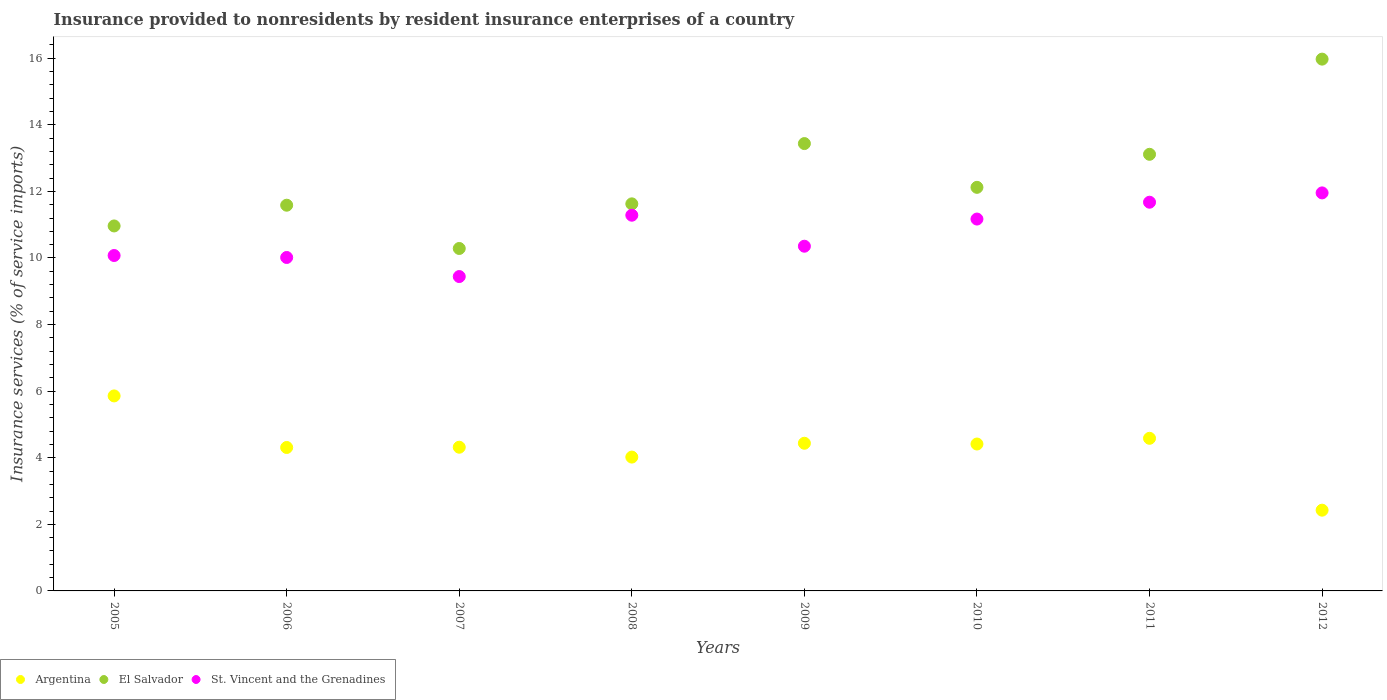What is the insurance provided to nonresidents in St. Vincent and the Grenadines in 2010?
Your answer should be very brief. 11.17. Across all years, what is the maximum insurance provided to nonresidents in El Salvador?
Your answer should be compact. 15.97. Across all years, what is the minimum insurance provided to nonresidents in St. Vincent and the Grenadines?
Keep it short and to the point. 9.44. In which year was the insurance provided to nonresidents in St. Vincent and the Grenadines maximum?
Your answer should be compact. 2012. In which year was the insurance provided to nonresidents in Argentina minimum?
Make the answer very short. 2012. What is the total insurance provided to nonresidents in El Salvador in the graph?
Offer a terse response. 99.11. What is the difference between the insurance provided to nonresidents in Argentina in 2005 and that in 2012?
Provide a succinct answer. 3.43. What is the difference between the insurance provided to nonresidents in St. Vincent and the Grenadines in 2011 and the insurance provided to nonresidents in El Salvador in 2010?
Your answer should be very brief. -0.45. What is the average insurance provided to nonresidents in St. Vincent and the Grenadines per year?
Provide a short and direct response. 10.75. In the year 2009, what is the difference between the insurance provided to nonresidents in St. Vincent and the Grenadines and insurance provided to nonresidents in El Salvador?
Make the answer very short. -3.08. What is the ratio of the insurance provided to nonresidents in St. Vincent and the Grenadines in 2005 to that in 2012?
Your answer should be very brief. 0.84. Is the difference between the insurance provided to nonresidents in St. Vincent and the Grenadines in 2005 and 2009 greater than the difference between the insurance provided to nonresidents in El Salvador in 2005 and 2009?
Your answer should be compact. Yes. What is the difference between the highest and the second highest insurance provided to nonresidents in Argentina?
Offer a terse response. 1.27. What is the difference between the highest and the lowest insurance provided to nonresidents in St. Vincent and the Grenadines?
Your response must be concise. 2.51. In how many years, is the insurance provided to nonresidents in Argentina greater than the average insurance provided to nonresidents in Argentina taken over all years?
Make the answer very short. 6. Is it the case that in every year, the sum of the insurance provided to nonresidents in El Salvador and insurance provided to nonresidents in Argentina  is greater than the insurance provided to nonresidents in St. Vincent and the Grenadines?
Offer a very short reply. Yes. How many years are there in the graph?
Your answer should be compact. 8. What is the difference between two consecutive major ticks on the Y-axis?
Keep it short and to the point. 2. Are the values on the major ticks of Y-axis written in scientific E-notation?
Your answer should be very brief. No. Where does the legend appear in the graph?
Your response must be concise. Bottom left. How are the legend labels stacked?
Provide a short and direct response. Horizontal. What is the title of the graph?
Your response must be concise. Insurance provided to nonresidents by resident insurance enterprises of a country. What is the label or title of the X-axis?
Your response must be concise. Years. What is the label or title of the Y-axis?
Provide a succinct answer. Insurance services (% of service imports). What is the Insurance services (% of service imports) in Argentina in 2005?
Offer a very short reply. 5.86. What is the Insurance services (% of service imports) in El Salvador in 2005?
Keep it short and to the point. 10.96. What is the Insurance services (% of service imports) in St. Vincent and the Grenadines in 2005?
Give a very brief answer. 10.07. What is the Insurance services (% of service imports) in Argentina in 2006?
Provide a short and direct response. 4.31. What is the Insurance services (% of service imports) in El Salvador in 2006?
Give a very brief answer. 11.59. What is the Insurance services (% of service imports) in St. Vincent and the Grenadines in 2006?
Make the answer very short. 10.02. What is the Insurance services (% of service imports) of Argentina in 2007?
Make the answer very short. 4.32. What is the Insurance services (% of service imports) of El Salvador in 2007?
Provide a short and direct response. 10.29. What is the Insurance services (% of service imports) of St. Vincent and the Grenadines in 2007?
Offer a very short reply. 9.44. What is the Insurance services (% of service imports) of Argentina in 2008?
Keep it short and to the point. 4.02. What is the Insurance services (% of service imports) of El Salvador in 2008?
Your answer should be very brief. 11.63. What is the Insurance services (% of service imports) in St. Vincent and the Grenadines in 2008?
Your answer should be compact. 11.28. What is the Insurance services (% of service imports) of Argentina in 2009?
Offer a very short reply. 4.44. What is the Insurance services (% of service imports) in El Salvador in 2009?
Your answer should be very brief. 13.44. What is the Insurance services (% of service imports) in St. Vincent and the Grenadines in 2009?
Your answer should be very brief. 10.35. What is the Insurance services (% of service imports) of Argentina in 2010?
Ensure brevity in your answer.  4.41. What is the Insurance services (% of service imports) of El Salvador in 2010?
Provide a succinct answer. 12.12. What is the Insurance services (% of service imports) in St. Vincent and the Grenadines in 2010?
Your answer should be very brief. 11.17. What is the Insurance services (% of service imports) in Argentina in 2011?
Keep it short and to the point. 4.58. What is the Insurance services (% of service imports) in El Salvador in 2011?
Provide a short and direct response. 13.11. What is the Insurance services (% of service imports) of St. Vincent and the Grenadines in 2011?
Provide a short and direct response. 11.68. What is the Insurance services (% of service imports) of Argentina in 2012?
Provide a succinct answer. 2.43. What is the Insurance services (% of service imports) of El Salvador in 2012?
Offer a terse response. 15.97. What is the Insurance services (% of service imports) of St. Vincent and the Grenadines in 2012?
Your answer should be very brief. 11.95. Across all years, what is the maximum Insurance services (% of service imports) in Argentina?
Your answer should be very brief. 5.86. Across all years, what is the maximum Insurance services (% of service imports) of El Salvador?
Provide a succinct answer. 15.97. Across all years, what is the maximum Insurance services (% of service imports) in St. Vincent and the Grenadines?
Make the answer very short. 11.95. Across all years, what is the minimum Insurance services (% of service imports) in Argentina?
Give a very brief answer. 2.43. Across all years, what is the minimum Insurance services (% of service imports) in El Salvador?
Ensure brevity in your answer.  10.29. Across all years, what is the minimum Insurance services (% of service imports) of St. Vincent and the Grenadines?
Your answer should be very brief. 9.44. What is the total Insurance services (% of service imports) in Argentina in the graph?
Give a very brief answer. 34.36. What is the total Insurance services (% of service imports) in El Salvador in the graph?
Offer a very short reply. 99.11. What is the total Insurance services (% of service imports) of St. Vincent and the Grenadines in the graph?
Your response must be concise. 85.97. What is the difference between the Insurance services (% of service imports) of Argentina in 2005 and that in 2006?
Give a very brief answer. 1.55. What is the difference between the Insurance services (% of service imports) of El Salvador in 2005 and that in 2006?
Offer a terse response. -0.62. What is the difference between the Insurance services (% of service imports) of St. Vincent and the Grenadines in 2005 and that in 2006?
Provide a succinct answer. 0.06. What is the difference between the Insurance services (% of service imports) in Argentina in 2005 and that in 2007?
Offer a very short reply. 1.54. What is the difference between the Insurance services (% of service imports) in El Salvador in 2005 and that in 2007?
Give a very brief answer. 0.68. What is the difference between the Insurance services (% of service imports) in St. Vincent and the Grenadines in 2005 and that in 2007?
Ensure brevity in your answer.  0.63. What is the difference between the Insurance services (% of service imports) in Argentina in 2005 and that in 2008?
Your answer should be very brief. 1.84. What is the difference between the Insurance services (% of service imports) of El Salvador in 2005 and that in 2008?
Your answer should be very brief. -0.66. What is the difference between the Insurance services (% of service imports) of St. Vincent and the Grenadines in 2005 and that in 2008?
Provide a succinct answer. -1.21. What is the difference between the Insurance services (% of service imports) in Argentina in 2005 and that in 2009?
Your response must be concise. 1.42. What is the difference between the Insurance services (% of service imports) in El Salvador in 2005 and that in 2009?
Provide a short and direct response. -2.47. What is the difference between the Insurance services (% of service imports) of St. Vincent and the Grenadines in 2005 and that in 2009?
Your answer should be very brief. -0.28. What is the difference between the Insurance services (% of service imports) of Argentina in 2005 and that in 2010?
Offer a very short reply. 1.45. What is the difference between the Insurance services (% of service imports) of El Salvador in 2005 and that in 2010?
Ensure brevity in your answer.  -1.16. What is the difference between the Insurance services (% of service imports) of St. Vincent and the Grenadines in 2005 and that in 2010?
Offer a very short reply. -1.09. What is the difference between the Insurance services (% of service imports) of Argentina in 2005 and that in 2011?
Provide a succinct answer. 1.27. What is the difference between the Insurance services (% of service imports) of El Salvador in 2005 and that in 2011?
Your answer should be compact. -2.15. What is the difference between the Insurance services (% of service imports) of St. Vincent and the Grenadines in 2005 and that in 2011?
Your answer should be compact. -1.6. What is the difference between the Insurance services (% of service imports) in Argentina in 2005 and that in 2012?
Keep it short and to the point. 3.43. What is the difference between the Insurance services (% of service imports) in El Salvador in 2005 and that in 2012?
Offer a very short reply. -5.01. What is the difference between the Insurance services (% of service imports) in St. Vincent and the Grenadines in 2005 and that in 2012?
Ensure brevity in your answer.  -1.88. What is the difference between the Insurance services (% of service imports) in Argentina in 2006 and that in 2007?
Give a very brief answer. -0.01. What is the difference between the Insurance services (% of service imports) of El Salvador in 2006 and that in 2007?
Make the answer very short. 1.3. What is the difference between the Insurance services (% of service imports) in St. Vincent and the Grenadines in 2006 and that in 2007?
Give a very brief answer. 0.57. What is the difference between the Insurance services (% of service imports) of Argentina in 2006 and that in 2008?
Provide a short and direct response. 0.29. What is the difference between the Insurance services (% of service imports) of El Salvador in 2006 and that in 2008?
Give a very brief answer. -0.04. What is the difference between the Insurance services (% of service imports) of St. Vincent and the Grenadines in 2006 and that in 2008?
Offer a terse response. -1.27. What is the difference between the Insurance services (% of service imports) of Argentina in 2006 and that in 2009?
Give a very brief answer. -0.13. What is the difference between the Insurance services (% of service imports) in El Salvador in 2006 and that in 2009?
Your answer should be very brief. -1.85. What is the difference between the Insurance services (% of service imports) in St. Vincent and the Grenadines in 2006 and that in 2009?
Keep it short and to the point. -0.34. What is the difference between the Insurance services (% of service imports) in Argentina in 2006 and that in 2010?
Offer a very short reply. -0.1. What is the difference between the Insurance services (% of service imports) in El Salvador in 2006 and that in 2010?
Offer a terse response. -0.54. What is the difference between the Insurance services (% of service imports) of St. Vincent and the Grenadines in 2006 and that in 2010?
Your response must be concise. -1.15. What is the difference between the Insurance services (% of service imports) in Argentina in 2006 and that in 2011?
Provide a short and direct response. -0.28. What is the difference between the Insurance services (% of service imports) in El Salvador in 2006 and that in 2011?
Ensure brevity in your answer.  -1.53. What is the difference between the Insurance services (% of service imports) in St. Vincent and the Grenadines in 2006 and that in 2011?
Make the answer very short. -1.66. What is the difference between the Insurance services (% of service imports) in Argentina in 2006 and that in 2012?
Provide a succinct answer. 1.88. What is the difference between the Insurance services (% of service imports) of El Salvador in 2006 and that in 2012?
Offer a terse response. -4.39. What is the difference between the Insurance services (% of service imports) in St. Vincent and the Grenadines in 2006 and that in 2012?
Keep it short and to the point. -1.94. What is the difference between the Insurance services (% of service imports) of Argentina in 2007 and that in 2008?
Offer a very short reply. 0.3. What is the difference between the Insurance services (% of service imports) in El Salvador in 2007 and that in 2008?
Offer a very short reply. -1.34. What is the difference between the Insurance services (% of service imports) in St. Vincent and the Grenadines in 2007 and that in 2008?
Ensure brevity in your answer.  -1.84. What is the difference between the Insurance services (% of service imports) of Argentina in 2007 and that in 2009?
Offer a very short reply. -0.12. What is the difference between the Insurance services (% of service imports) of El Salvador in 2007 and that in 2009?
Make the answer very short. -3.15. What is the difference between the Insurance services (% of service imports) of St. Vincent and the Grenadines in 2007 and that in 2009?
Keep it short and to the point. -0.91. What is the difference between the Insurance services (% of service imports) in Argentina in 2007 and that in 2010?
Your answer should be very brief. -0.1. What is the difference between the Insurance services (% of service imports) in El Salvador in 2007 and that in 2010?
Offer a very short reply. -1.84. What is the difference between the Insurance services (% of service imports) in St. Vincent and the Grenadines in 2007 and that in 2010?
Offer a terse response. -1.73. What is the difference between the Insurance services (% of service imports) in Argentina in 2007 and that in 2011?
Make the answer very short. -0.27. What is the difference between the Insurance services (% of service imports) of El Salvador in 2007 and that in 2011?
Your answer should be very brief. -2.83. What is the difference between the Insurance services (% of service imports) in St. Vincent and the Grenadines in 2007 and that in 2011?
Ensure brevity in your answer.  -2.23. What is the difference between the Insurance services (% of service imports) in Argentina in 2007 and that in 2012?
Make the answer very short. 1.89. What is the difference between the Insurance services (% of service imports) of El Salvador in 2007 and that in 2012?
Your response must be concise. -5.69. What is the difference between the Insurance services (% of service imports) in St. Vincent and the Grenadines in 2007 and that in 2012?
Your answer should be compact. -2.51. What is the difference between the Insurance services (% of service imports) in Argentina in 2008 and that in 2009?
Make the answer very short. -0.42. What is the difference between the Insurance services (% of service imports) of El Salvador in 2008 and that in 2009?
Your answer should be very brief. -1.81. What is the difference between the Insurance services (% of service imports) in St. Vincent and the Grenadines in 2008 and that in 2009?
Make the answer very short. 0.93. What is the difference between the Insurance services (% of service imports) of Argentina in 2008 and that in 2010?
Your answer should be very brief. -0.39. What is the difference between the Insurance services (% of service imports) of El Salvador in 2008 and that in 2010?
Keep it short and to the point. -0.5. What is the difference between the Insurance services (% of service imports) in St. Vincent and the Grenadines in 2008 and that in 2010?
Your response must be concise. 0.12. What is the difference between the Insurance services (% of service imports) of Argentina in 2008 and that in 2011?
Offer a terse response. -0.56. What is the difference between the Insurance services (% of service imports) in El Salvador in 2008 and that in 2011?
Offer a very short reply. -1.49. What is the difference between the Insurance services (% of service imports) of St. Vincent and the Grenadines in 2008 and that in 2011?
Provide a succinct answer. -0.39. What is the difference between the Insurance services (% of service imports) of Argentina in 2008 and that in 2012?
Offer a terse response. 1.59. What is the difference between the Insurance services (% of service imports) in El Salvador in 2008 and that in 2012?
Provide a short and direct response. -4.35. What is the difference between the Insurance services (% of service imports) of St. Vincent and the Grenadines in 2008 and that in 2012?
Your response must be concise. -0.67. What is the difference between the Insurance services (% of service imports) in Argentina in 2009 and that in 2010?
Your response must be concise. 0.02. What is the difference between the Insurance services (% of service imports) of El Salvador in 2009 and that in 2010?
Your answer should be very brief. 1.31. What is the difference between the Insurance services (% of service imports) in St. Vincent and the Grenadines in 2009 and that in 2010?
Your answer should be compact. -0.82. What is the difference between the Insurance services (% of service imports) of Argentina in 2009 and that in 2011?
Offer a terse response. -0.15. What is the difference between the Insurance services (% of service imports) in El Salvador in 2009 and that in 2011?
Offer a very short reply. 0.32. What is the difference between the Insurance services (% of service imports) of St. Vincent and the Grenadines in 2009 and that in 2011?
Keep it short and to the point. -1.32. What is the difference between the Insurance services (% of service imports) in Argentina in 2009 and that in 2012?
Your answer should be very brief. 2.01. What is the difference between the Insurance services (% of service imports) in El Salvador in 2009 and that in 2012?
Keep it short and to the point. -2.54. What is the difference between the Insurance services (% of service imports) in St. Vincent and the Grenadines in 2009 and that in 2012?
Your response must be concise. -1.6. What is the difference between the Insurance services (% of service imports) in Argentina in 2010 and that in 2011?
Give a very brief answer. -0.17. What is the difference between the Insurance services (% of service imports) in El Salvador in 2010 and that in 2011?
Offer a very short reply. -0.99. What is the difference between the Insurance services (% of service imports) of St. Vincent and the Grenadines in 2010 and that in 2011?
Your answer should be very brief. -0.51. What is the difference between the Insurance services (% of service imports) in Argentina in 2010 and that in 2012?
Offer a very short reply. 1.99. What is the difference between the Insurance services (% of service imports) of El Salvador in 2010 and that in 2012?
Ensure brevity in your answer.  -3.85. What is the difference between the Insurance services (% of service imports) in St. Vincent and the Grenadines in 2010 and that in 2012?
Provide a succinct answer. -0.79. What is the difference between the Insurance services (% of service imports) in Argentina in 2011 and that in 2012?
Offer a terse response. 2.16. What is the difference between the Insurance services (% of service imports) in El Salvador in 2011 and that in 2012?
Make the answer very short. -2.86. What is the difference between the Insurance services (% of service imports) in St. Vincent and the Grenadines in 2011 and that in 2012?
Offer a terse response. -0.28. What is the difference between the Insurance services (% of service imports) of Argentina in 2005 and the Insurance services (% of service imports) of El Salvador in 2006?
Keep it short and to the point. -5.73. What is the difference between the Insurance services (% of service imports) of Argentina in 2005 and the Insurance services (% of service imports) of St. Vincent and the Grenadines in 2006?
Ensure brevity in your answer.  -4.16. What is the difference between the Insurance services (% of service imports) of El Salvador in 2005 and the Insurance services (% of service imports) of St. Vincent and the Grenadines in 2006?
Keep it short and to the point. 0.95. What is the difference between the Insurance services (% of service imports) in Argentina in 2005 and the Insurance services (% of service imports) in El Salvador in 2007?
Make the answer very short. -4.43. What is the difference between the Insurance services (% of service imports) of Argentina in 2005 and the Insurance services (% of service imports) of St. Vincent and the Grenadines in 2007?
Your answer should be very brief. -3.58. What is the difference between the Insurance services (% of service imports) in El Salvador in 2005 and the Insurance services (% of service imports) in St. Vincent and the Grenadines in 2007?
Your answer should be compact. 1.52. What is the difference between the Insurance services (% of service imports) of Argentina in 2005 and the Insurance services (% of service imports) of El Salvador in 2008?
Keep it short and to the point. -5.77. What is the difference between the Insurance services (% of service imports) of Argentina in 2005 and the Insurance services (% of service imports) of St. Vincent and the Grenadines in 2008?
Offer a terse response. -5.43. What is the difference between the Insurance services (% of service imports) of El Salvador in 2005 and the Insurance services (% of service imports) of St. Vincent and the Grenadines in 2008?
Provide a short and direct response. -0.32. What is the difference between the Insurance services (% of service imports) in Argentina in 2005 and the Insurance services (% of service imports) in El Salvador in 2009?
Your answer should be compact. -7.58. What is the difference between the Insurance services (% of service imports) of Argentina in 2005 and the Insurance services (% of service imports) of St. Vincent and the Grenadines in 2009?
Your answer should be very brief. -4.5. What is the difference between the Insurance services (% of service imports) in El Salvador in 2005 and the Insurance services (% of service imports) in St. Vincent and the Grenadines in 2009?
Give a very brief answer. 0.61. What is the difference between the Insurance services (% of service imports) in Argentina in 2005 and the Insurance services (% of service imports) in El Salvador in 2010?
Provide a succinct answer. -6.26. What is the difference between the Insurance services (% of service imports) of Argentina in 2005 and the Insurance services (% of service imports) of St. Vincent and the Grenadines in 2010?
Offer a very short reply. -5.31. What is the difference between the Insurance services (% of service imports) in El Salvador in 2005 and the Insurance services (% of service imports) in St. Vincent and the Grenadines in 2010?
Offer a very short reply. -0.21. What is the difference between the Insurance services (% of service imports) of Argentina in 2005 and the Insurance services (% of service imports) of El Salvador in 2011?
Your answer should be very brief. -7.26. What is the difference between the Insurance services (% of service imports) of Argentina in 2005 and the Insurance services (% of service imports) of St. Vincent and the Grenadines in 2011?
Ensure brevity in your answer.  -5.82. What is the difference between the Insurance services (% of service imports) in El Salvador in 2005 and the Insurance services (% of service imports) in St. Vincent and the Grenadines in 2011?
Your answer should be compact. -0.71. What is the difference between the Insurance services (% of service imports) in Argentina in 2005 and the Insurance services (% of service imports) in El Salvador in 2012?
Your answer should be compact. -10.12. What is the difference between the Insurance services (% of service imports) of Argentina in 2005 and the Insurance services (% of service imports) of St. Vincent and the Grenadines in 2012?
Offer a very short reply. -6.1. What is the difference between the Insurance services (% of service imports) of El Salvador in 2005 and the Insurance services (% of service imports) of St. Vincent and the Grenadines in 2012?
Your response must be concise. -0.99. What is the difference between the Insurance services (% of service imports) in Argentina in 2006 and the Insurance services (% of service imports) in El Salvador in 2007?
Provide a short and direct response. -5.98. What is the difference between the Insurance services (% of service imports) of Argentina in 2006 and the Insurance services (% of service imports) of St. Vincent and the Grenadines in 2007?
Your answer should be compact. -5.13. What is the difference between the Insurance services (% of service imports) of El Salvador in 2006 and the Insurance services (% of service imports) of St. Vincent and the Grenadines in 2007?
Provide a succinct answer. 2.14. What is the difference between the Insurance services (% of service imports) in Argentina in 2006 and the Insurance services (% of service imports) in El Salvador in 2008?
Your response must be concise. -7.32. What is the difference between the Insurance services (% of service imports) of Argentina in 2006 and the Insurance services (% of service imports) of St. Vincent and the Grenadines in 2008?
Your answer should be compact. -6.98. What is the difference between the Insurance services (% of service imports) in El Salvador in 2006 and the Insurance services (% of service imports) in St. Vincent and the Grenadines in 2008?
Ensure brevity in your answer.  0.3. What is the difference between the Insurance services (% of service imports) of Argentina in 2006 and the Insurance services (% of service imports) of El Salvador in 2009?
Give a very brief answer. -9.13. What is the difference between the Insurance services (% of service imports) in Argentina in 2006 and the Insurance services (% of service imports) in St. Vincent and the Grenadines in 2009?
Give a very brief answer. -6.05. What is the difference between the Insurance services (% of service imports) in El Salvador in 2006 and the Insurance services (% of service imports) in St. Vincent and the Grenadines in 2009?
Make the answer very short. 1.23. What is the difference between the Insurance services (% of service imports) in Argentina in 2006 and the Insurance services (% of service imports) in El Salvador in 2010?
Keep it short and to the point. -7.81. What is the difference between the Insurance services (% of service imports) in Argentina in 2006 and the Insurance services (% of service imports) in St. Vincent and the Grenadines in 2010?
Your answer should be very brief. -6.86. What is the difference between the Insurance services (% of service imports) in El Salvador in 2006 and the Insurance services (% of service imports) in St. Vincent and the Grenadines in 2010?
Your answer should be very brief. 0.42. What is the difference between the Insurance services (% of service imports) of Argentina in 2006 and the Insurance services (% of service imports) of El Salvador in 2011?
Ensure brevity in your answer.  -8.81. What is the difference between the Insurance services (% of service imports) of Argentina in 2006 and the Insurance services (% of service imports) of St. Vincent and the Grenadines in 2011?
Give a very brief answer. -7.37. What is the difference between the Insurance services (% of service imports) in El Salvador in 2006 and the Insurance services (% of service imports) in St. Vincent and the Grenadines in 2011?
Your answer should be compact. -0.09. What is the difference between the Insurance services (% of service imports) in Argentina in 2006 and the Insurance services (% of service imports) in El Salvador in 2012?
Provide a succinct answer. -11.66. What is the difference between the Insurance services (% of service imports) of Argentina in 2006 and the Insurance services (% of service imports) of St. Vincent and the Grenadines in 2012?
Provide a short and direct response. -7.65. What is the difference between the Insurance services (% of service imports) in El Salvador in 2006 and the Insurance services (% of service imports) in St. Vincent and the Grenadines in 2012?
Your answer should be compact. -0.37. What is the difference between the Insurance services (% of service imports) in Argentina in 2007 and the Insurance services (% of service imports) in El Salvador in 2008?
Make the answer very short. -7.31. What is the difference between the Insurance services (% of service imports) of Argentina in 2007 and the Insurance services (% of service imports) of St. Vincent and the Grenadines in 2008?
Ensure brevity in your answer.  -6.97. What is the difference between the Insurance services (% of service imports) in El Salvador in 2007 and the Insurance services (% of service imports) in St. Vincent and the Grenadines in 2008?
Make the answer very short. -1. What is the difference between the Insurance services (% of service imports) of Argentina in 2007 and the Insurance services (% of service imports) of El Salvador in 2009?
Make the answer very short. -9.12. What is the difference between the Insurance services (% of service imports) in Argentina in 2007 and the Insurance services (% of service imports) in St. Vincent and the Grenadines in 2009?
Keep it short and to the point. -6.04. What is the difference between the Insurance services (% of service imports) of El Salvador in 2007 and the Insurance services (% of service imports) of St. Vincent and the Grenadines in 2009?
Your answer should be compact. -0.07. What is the difference between the Insurance services (% of service imports) in Argentina in 2007 and the Insurance services (% of service imports) in El Salvador in 2010?
Make the answer very short. -7.81. What is the difference between the Insurance services (% of service imports) in Argentina in 2007 and the Insurance services (% of service imports) in St. Vincent and the Grenadines in 2010?
Provide a succinct answer. -6.85. What is the difference between the Insurance services (% of service imports) in El Salvador in 2007 and the Insurance services (% of service imports) in St. Vincent and the Grenadines in 2010?
Provide a short and direct response. -0.88. What is the difference between the Insurance services (% of service imports) of Argentina in 2007 and the Insurance services (% of service imports) of El Salvador in 2011?
Your answer should be very brief. -8.8. What is the difference between the Insurance services (% of service imports) in Argentina in 2007 and the Insurance services (% of service imports) in St. Vincent and the Grenadines in 2011?
Provide a short and direct response. -7.36. What is the difference between the Insurance services (% of service imports) in El Salvador in 2007 and the Insurance services (% of service imports) in St. Vincent and the Grenadines in 2011?
Provide a succinct answer. -1.39. What is the difference between the Insurance services (% of service imports) of Argentina in 2007 and the Insurance services (% of service imports) of El Salvador in 2012?
Your answer should be very brief. -11.66. What is the difference between the Insurance services (% of service imports) of Argentina in 2007 and the Insurance services (% of service imports) of St. Vincent and the Grenadines in 2012?
Ensure brevity in your answer.  -7.64. What is the difference between the Insurance services (% of service imports) in El Salvador in 2007 and the Insurance services (% of service imports) in St. Vincent and the Grenadines in 2012?
Keep it short and to the point. -1.67. What is the difference between the Insurance services (% of service imports) in Argentina in 2008 and the Insurance services (% of service imports) in El Salvador in 2009?
Provide a succinct answer. -9.42. What is the difference between the Insurance services (% of service imports) in Argentina in 2008 and the Insurance services (% of service imports) in St. Vincent and the Grenadines in 2009?
Your response must be concise. -6.33. What is the difference between the Insurance services (% of service imports) of El Salvador in 2008 and the Insurance services (% of service imports) of St. Vincent and the Grenadines in 2009?
Offer a very short reply. 1.27. What is the difference between the Insurance services (% of service imports) of Argentina in 2008 and the Insurance services (% of service imports) of El Salvador in 2010?
Your answer should be very brief. -8.1. What is the difference between the Insurance services (% of service imports) of Argentina in 2008 and the Insurance services (% of service imports) of St. Vincent and the Grenadines in 2010?
Give a very brief answer. -7.15. What is the difference between the Insurance services (% of service imports) in El Salvador in 2008 and the Insurance services (% of service imports) in St. Vincent and the Grenadines in 2010?
Give a very brief answer. 0.46. What is the difference between the Insurance services (% of service imports) of Argentina in 2008 and the Insurance services (% of service imports) of El Salvador in 2011?
Provide a short and direct response. -9.09. What is the difference between the Insurance services (% of service imports) of Argentina in 2008 and the Insurance services (% of service imports) of St. Vincent and the Grenadines in 2011?
Give a very brief answer. -7.66. What is the difference between the Insurance services (% of service imports) in El Salvador in 2008 and the Insurance services (% of service imports) in St. Vincent and the Grenadines in 2011?
Provide a short and direct response. -0.05. What is the difference between the Insurance services (% of service imports) in Argentina in 2008 and the Insurance services (% of service imports) in El Salvador in 2012?
Keep it short and to the point. -11.95. What is the difference between the Insurance services (% of service imports) in Argentina in 2008 and the Insurance services (% of service imports) in St. Vincent and the Grenadines in 2012?
Your response must be concise. -7.94. What is the difference between the Insurance services (% of service imports) of El Salvador in 2008 and the Insurance services (% of service imports) of St. Vincent and the Grenadines in 2012?
Ensure brevity in your answer.  -0.33. What is the difference between the Insurance services (% of service imports) in Argentina in 2009 and the Insurance services (% of service imports) in El Salvador in 2010?
Keep it short and to the point. -7.69. What is the difference between the Insurance services (% of service imports) of Argentina in 2009 and the Insurance services (% of service imports) of St. Vincent and the Grenadines in 2010?
Keep it short and to the point. -6.73. What is the difference between the Insurance services (% of service imports) in El Salvador in 2009 and the Insurance services (% of service imports) in St. Vincent and the Grenadines in 2010?
Make the answer very short. 2.27. What is the difference between the Insurance services (% of service imports) in Argentina in 2009 and the Insurance services (% of service imports) in El Salvador in 2011?
Offer a very short reply. -8.68. What is the difference between the Insurance services (% of service imports) in Argentina in 2009 and the Insurance services (% of service imports) in St. Vincent and the Grenadines in 2011?
Offer a terse response. -7.24. What is the difference between the Insurance services (% of service imports) in El Salvador in 2009 and the Insurance services (% of service imports) in St. Vincent and the Grenadines in 2011?
Your response must be concise. 1.76. What is the difference between the Insurance services (% of service imports) in Argentina in 2009 and the Insurance services (% of service imports) in El Salvador in 2012?
Offer a very short reply. -11.54. What is the difference between the Insurance services (% of service imports) of Argentina in 2009 and the Insurance services (% of service imports) of St. Vincent and the Grenadines in 2012?
Ensure brevity in your answer.  -7.52. What is the difference between the Insurance services (% of service imports) in El Salvador in 2009 and the Insurance services (% of service imports) in St. Vincent and the Grenadines in 2012?
Give a very brief answer. 1.48. What is the difference between the Insurance services (% of service imports) of Argentina in 2010 and the Insurance services (% of service imports) of El Salvador in 2011?
Offer a very short reply. -8.7. What is the difference between the Insurance services (% of service imports) of Argentina in 2010 and the Insurance services (% of service imports) of St. Vincent and the Grenadines in 2011?
Give a very brief answer. -7.26. What is the difference between the Insurance services (% of service imports) in El Salvador in 2010 and the Insurance services (% of service imports) in St. Vincent and the Grenadines in 2011?
Offer a terse response. 0.45. What is the difference between the Insurance services (% of service imports) in Argentina in 2010 and the Insurance services (% of service imports) in El Salvador in 2012?
Your response must be concise. -11.56. What is the difference between the Insurance services (% of service imports) of Argentina in 2010 and the Insurance services (% of service imports) of St. Vincent and the Grenadines in 2012?
Your response must be concise. -7.54. What is the difference between the Insurance services (% of service imports) of El Salvador in 2010 and the Insurance services (% of service imports) of St. Vincent and the Grenadines in 2012?
Keep it short and to the point. 0.17. What is the difference between the Insurance services (% of service imports) in Argentina in 2011 and the Insurance services (% of service imports) in El Salvador in 2012?
Provide a short and direct response. -11.39. What is the difference between the Insurance services (% of service imports) of Argentina in 2011 and the Insurance services (% of service imports) of St. Vincent and the Grenadines in 2012?
Offer a terse response. -7.37. What is the difference between the Insurance services (% of service imports) in El Salvador in 2011 and the Insurance services (% of service imports) in St. Vincent and the Grenadines in 2012?
Provide a succinct answer. 1.16. What is the average Insurance services (% of service imports) in Argentina per year?
Your answer should be very brief. 4.29. What is the average Insurance services (% of service imports) in El Salvador per year?
Offer a very short reply. 12.39. What is the average Insurance services (% of service imports) in St. Vincent and the Grenadines per year?
Your response must be concise. 10.75. In the year 2005, what is the difference between the Insurance services (% of service imports) of Argentina and Insurance services (% of service imports) of El Salvador?
Provide a short and direct response. -5.11. In the year 2005, what is the difference between the Insurance services (% of service imports) of Argentina and Insurance services (% of service imports) of St. Vincent and the Grenadines?
Give a very brief answer. -4.22. In the year 2005, what is the difference between the Insurance services (% of service imports) of El Salvador and Insurance services (% of service imports) of St. Vincent and the Grenadines?
Provide a succinct answer. 0.89. In the year 2006, what is the difference between the Insurance services (% of service imports) of Argentina and Insurance services (% of service imports) of El Salvador?
Your response must be concise. -7.28. In the year 2006, what is the difference between the Insurance services (% of service imports) of Argentina and Insurance services (% of service imports) of St. Vincent and the Grenadines?
Your answer should be compact. -5.71. In the year 2006, what is the difference between the Insurance services (% of service imports) in El Salvador and Insurance services (% of service imports) in St. Vincent and the Grenadines?
Give a very brief answer. 1.57. In the year 2007, what is the difference between the Insurance services (% of service imports) in Argentina and Insurance services (% of service imports) in El Salvador?
Your answer should be compact. -5.97. In the year 2007, what is the difference between the Insurance services (% of service imports) in Argentina and Insurance services (% of service imports) in St. Vincent and the Grenadines?
Provide a succinct answer. -5.13. In the year 2007, what is the difference between the Insurance services (% of service imports) of El Salvador and Insurance services (% of service imports) of St. Vincent and the Grenadines?
Offer a terse response. 0.84. In the year 2008, what is the difference between the Insurance services (% of service imports) of Argentina and Insurance services (% of service imports) of El Salvador?
Provide a succinct answer. -7.61. In the year 2008, what is the difference between the Insurance services (% of service imports) in Argentina and Insurance services (% of service imports) in St. Vincent and the Grenadines?
Ensure brevity in your answer.  -7.26. In the year 2008, what is the difference between the Insurance services (% of service imports) in El Salvador and Insurance services (% of service imports) in St. Vincent and the Grenadines?
Keep it short and to the point. 0.34. In the year 2009, what is the difference between the Insurance services (% of service imports) in Argentina and Insurance services (% of service imports) in El Salvador?
Provide a short and direct response. -9. In the year 2009, what is the difference between the Insurance services (% of service imports) in Argentina and Insurance services (% of service imports) in St. Vincent and the Grenadines?
Ensure brevity in your answer.  -5.92. In the year 2009, what is the difference between the Insurance services (% of service imports) of El Salvador and Insurance services (% of service imports) of St. Vincent and the Grenadines?
Provide a succinct answer. 3.08. In the year 2010, what is the difference between the Insurance services (% of service imports) in Argentina and Insurance services (% of service imports) in El Salvador?
Your answer should be compact. -7.71. In the year 2010, what is the difference between the Insurance services (% of service imports) of Argentina and Insurance services (% of service imports) of St. Vincent and the Grenadines?
Your answer should be compact. -6.76. In the year 2010, what is the difference between the Insurance services (% of service imports) in El Salvador and Insurance services (% of service imports) in St. Vincent and the Grenadines?
Offer a terse response. 0.95. In the year 2011, what is the difference between the Insurance services (% of service imports) of Argentina and Insurance services (% of service imports) of El Salvador?
Ensure brevity in your answer.  -8.53. In the year 2011, what is the difference between the Insurance services (% of service imports) in Argentina and Insurance services (% of service imports) in St. Vincent and the Grenadines?
Give a very brief answer. -7.09. In the year 2011, what is the difference between the Insurance services (% of service imports) in El Salvador and Insurance services (% of service imports) in St. Vincent and the Grenadines?
Your answer should be compact. 1.44. In the year 2012, what is the difference between the Insurance services (% of service imports) of Argentina and Insurance services (% of service imports) of El Salvador?
Offer a terse response. -13.55. In the year 2012, what is the difference between the Insurance services (% of service imports) of Argentina and Insurance services (% of service imports) of St. Vincent and the Grenadines?
Offer a very short reply. -9.53. In the year 2012, what is the difference between the Insurance services (% of service imports) in El Salvador and Insurance services (% of service imports) in St. Vincent and the Grenadines?
Provide a short and direct response. 4.02. What is the ratio of the Insurance services (% of service imports) of Argentina in 2005 to that in 2006?
Ensure brevity in your answer.  1.36. What is the ratio of the Insurance services (% of service imports) of El Salvador in 2005 to that in 2006?
Offer a terse response. 0.95. What is the ratio of the Insurance services (% of service imports) of St. Vincent and the Grenadines in 2005 to that in 2006?
Your answer should be compact. 1.01. What is the ratio of the Insurance services (% of service imports) in Argentina in 2005 to that in 2007?
Offer a terse response. 1.36. What is the ratio of the Insurance services (% of service imports) of El Salvador in 2005 to that in 2007?
Provide a succinct answer. 1.07. What is the ratio of the Insurance services (% of service imports) in St. Vincent and the Grenadines in 2005 to that in 2007?
Provide a succinct answer. 1.07. What is the ratio of the Insurance services (% of service imports) in Argentina in 2005 to that in 2008?
Ensure brevity in your answer.  1.46. What is the ratio of the Insurance services (% of service imports) of El Salvador in 2005 to that in 2008?
Provide a short and direct response. 0.94. What is the ratio of the Insurance services (% of service imports) in St. Vincent and the Grenadines in 2005 to that in 2008?
Give a very brief answer. 0.89. What is the ratio of the Insurance services (% of service imports) of Argentina in 2005 to that in 2009?
Provide a short and direct response. 1.32. What is the ratio of the Insurance services (% of service imports) of El Salvador in 2005 to that in 2009?
Give a very brief answer. 0.82. What is the ratio of the Insurance services (% of service imports) of St. Vincent and the Grenadines in 2005 to that in 2009?
Ensure brevity in your answer.  0.97. What is the ratio of the Insurance services (% of service imports) of Argentina in 2005 to that in 2010?
Offer a very short reply. 1.33. What is the ratio of the Insurance services (% of service imports) of El Salvador in 2005 to that in 2010?
Ensure brevity in your answer.  0.9. What is the ratio of the Insurance services (% of service imports) of St. Vincent and the Grenadines in 2005 to that in 2010?
Your answer should be compact. 0.9. What is the ratio of the Insurance services (% of service imports) of Argentina in 2005 to that in 2011?
Provide a short and direct response. 1.28. What is the ratio of the Insurance services (% of service imports) of El Salvador in 2005 to that in 2011?
Your answer should be very brief. 0.84. What is the ratio of the Insurance services (% of service imports) in St. Vincent and the Grenadines in 2005 to that in 2011?
Make the answer very short. 0.86. What is the ratio of the Insurance services (% of service imports) in Argentina in 2005 to that in 2012?
Give a very brief answer. 2.42. What is the ratio of the Insurance services (% of service imports) in El Salvador in 2005 to that in 2012?
Offer a terse response. 0.69. What is the ratio of the Insurance services (% of service imports) of St. Vincent and the Grenadines in 2005 to that in 2012?
Offer a very short reply. 0.84. What is the ratio of the Insurance services (% of service imports) of El Salvador in 2006 to that in 2007?
Provide a succinct answer. 1.13. What is the ratio of the Insurance services (% of service imports) in St. Vincent and the Grenadines in 2006 to that in 2007?
Provide a short and direct response. 1.06. What is the ratio of the Insurance services (% of service imports) in Argentina in 2006 to that in 2008?
Provide a succinct answer. 1.07. What is the ratio of the Insurance services (% of service imports) of St. Vincent and the Grenadines in 2006 to that in 2008?
Ensure brevity in your answer.  0.89. What is the ratio of the Insurance services (% of service imports) in Argentina in 2006 to that in 2009?
Provide a succinct answer. 0.97. What is the ratio of the Insurance services (% of service imports) of El Salvador in 2006 to that in 2009?
Ensure brevity in your answer.  0.86. What is the ratio of the Insurance services (% of service imports) in St. Vincent and the Grenadines in 2006 to that in 2009?
Your answer should be compact. 0.97. What is the ratio of the Insurance services (% of service imports) of Argentina in 2006 to that in 2010?
Your answer should be very brief. 0.98. What is the ratio of the Insurance services (% of service imports) in El Salvador in 2006 to that in 2010?
Your answer should be very brief. 0.96. What is the ratio of the Insurance services (% of service imports) of St. Vincent and the Grenadines in 2006 to that in 2010?
Your answer should be compact. 0.9. What is the ratio of the Insurance services (% of service imports) of Argentina in 2006 to that in 2011?
Offer a terse response. 0.94. What is the ratio of the Insurance services (% of service imports) in El Salvador in 2006 to that in 2011?
Provide a short and direct response. 0.88. What is the ratio of the Insurance services (% of service imports) of St. Vincent and the Grenadines in 2006 to that in 2011?
Give a very brief answer. 0.86. What is the ratio of the Insurance services (% of service imports) of Argentina in 2006 to that in 2012?
Provide a succinct answer. 1.78. What is the ratio of the Insurance services (% of service imports) in El Salvador in 2006 to that in 2012?
Keep it short and to the point. 0.73. What is the ratio of the Insurance services (% of service imports) of St. Vincent and the Grenadines in 2006 to that in 2012?
Your answer should be compact. 0.84. What is the ratio of the Insurance services (% of service imports) in Argentina in 2007 to that in 2008?
Make the answer very short. 1.07. What is the ratio of the Insurance services (% of service imports) of El Salvador in 2007 to that in 2008?
Your response must be concise. 0.88. What is the ratio of the Insurance services (% of service imports) of St. Vincent and the Grenadines in 2007 to that in 2008?
Your answer should be compact. 0.84. What is the ratio of the Insurance services (% of service imports) of Argentina in 2007 to that in 2009?
Provide a succinct answer. 0.97. What is the ratio of the Insurance services (% of service imports) of El Salvador in 2007 to that in 2009?
Give a very brief answer. 0.77. What is the ratio of the Insurance services (% of service imports) in St. Vincent and the Grenadines in 2007 to that in 2009?
Ensure brevity in your answer.  0.91. What is the ratio of the Insurance services (% of service imports) of Argentina in 2007 to that in 2010?
Your answer should be very brief. 0.98. What is the ratio of the Insurance services (% of service imports) in El Salvador in 2007 to that in 2010?
Offer a terse response. 0.85. What is the ratio of the Insurance services (% of service imports) in St. Vincent and the Grenadines in 2007 to that in 2010?
Keep it short and to the point. 0.85. What is the ratio of the Insurance services (% of service imports) in Argentina in 2007 to that in 2011?
Ensure brevity in your answer.  0.94. What is the ratio of the Insurance services (% of service imports) of El Salvador in 2007 to that in 2011?
Your answer should be very brief. 0.78. What is the ratio of the Insurance services (% of service imports) of St. Vincent and the Grenadines in 2007 to that in 2011?
Keep it short and to the point. 0.81. What is the ratio of the Insurance services (% of service imports) of Argentina in 2007 to that in 2012?
Keep it short and to the point. 1.78. What is the ratio of the Insurance services (% of service imports) of El Salvador in 2007 to that in 2012?
Give a very brief answer. 0.64. What is the ratio of the Insurance services (% of service imports) of St. Vincent and the Grenadines in 2007 to that in 2012?
Give a very brief answer. 0.79. What is the ratio of the Insurance services (% of service imports) of Argentina in 2008 to that in 2009?
Give a very brief answer. 0.91. What is the ratio of the Insurance services (% of service imports) in El Salvador in 2008 to that in 2009?
Keep it short and to the point. 0.87. What is the ratio of the Insurance services (% of service imports) of St. Vincent and the Grenadines in 2008 to that in 2009?
Offer a terse response. 1.09. What is the ratio of the Insurance services (% of service imports) of Argentina in 2008 to that in 2010?
Ensure brevity in your answer.  0.91. What is the ratio of the Insurance services (% of service imports) in El Salvador in 2008 to that in 2010?
Provide a succinct answer. 0.96. What is the ratio of the Insurance services (% of service imports) of St. Vincent and the Grenadines in 2008 to that in 2010?
Ensure brevity in your answer.  1.01. What is the ratio of the Insurance services (% of service imports) in Argentina in 2008 to that in 2011?
Your answer should be compact. 0.88. What is the ratio of the Insurance services (% of service imports) in El Salvador in 2008 to that in 2011?
Your answer should be very brief. 0.89. What is the ratio of the Insurance services (% of service imports) of St. Vincent and the Grenadines in 2008 to that in 2011?
Provide a short and direct response. 0.97. What is the ratio of the Insurance services (% of service imports) in Argentina in 2008 to that in 2012?
Your response must be concise. 1.66. What is the ratio of the Insurance services (% of service imports) of El Salvador in 2008 to that in 2012?
Your answer should be compact. 0.73. What is the ratio of the Insurance services (% of service imports) of St. Vincent and the Grenadines in 2008 to that in 2012?
Make the answer very short. 0.94. What is the ratio of the Insurance services (% of service imports) in Argentina in 2009 to that in 2010?
Provide a succinct answer. 1.01. What is the ratio of the Insurance services (% of service imports) of El Salvador in 2009 to that in 2010?
Offer a terse response. 1.11. What is the ratio of the Insurance services (% of service imports) in St. Vincent and the Grenadines in 2009 to that in 2010?
Provide a succinct answer. 0.93. What is the ratio of the Insurance services (% of service imports) in Argentina in 2009 to that in 2011?
Keep it short and to the point. 0.97. What is the ratio of the Insurance services (% of service imports) in El Salvador in 2009 to that in 2011?
Ensure brevity in your answer.  1.02. What is the ratio of the Insurance services (% of service imports) of St. Vincent and the Grenadines in 2009 to that in 2011?
Your response must be concise. 0.89. What is the ratio of the Insurance services (% of service imports) of Argentina in 2009 to that in 2012?
Your answer should be very brief. 1.83. What is the ratio of the Insurance services (% of service imports) in El Salvador in 2009 to that in 2012?
Provide a short and direct response. 0.84. What is the ratio of the Insurance services (% of service imports) in St. Vincent and the Grenadines in 2009 to that in 2012?
Offer a terse response. 0.87. What is the ratio of the Insurance services (% of service imports) of Argentina in 2010 to that in 2011?
Provide a succinct answer. 0.96. What is the ratio of the Insurance services (% of service imports) in El Salvador in 2010 to that in 2011?
Keep it short and to the point. 0.92. What is the ratio of the Insurance services (% of service imports) of St. Vincent and the Grenadines in 2010 to that in 2011?
Offer a very short reply. 0.96. What is the ratio of the Insurance services (% of service imports) of Argentina in 2010 to that in 2012?
Keep it short and to the point. 1.82. What is the ratio of the Insurance services (% of service imports) of El Salvador in 2010 to that in 2012?
Your answer should be compact. 0.76. What is the ratio of the Insurance services (% of service imports) in St. Vincent and the Grenadines in 2010 to that in 2012?
Your response must be concise. 0.93. What is the ratio of the Insurance services (% of service imports) of Argentina in 2011 to that in 2012?
Make the answer very short. 1.89. What is the ratio of the Insurance services (% of service imports) in El Salvador in 2011 to that in 2012?
Keep it short and to the point. 0.82. What is the ratio of the Insurance services (% of service imports) in St. Vincent and the Grenadines in 2011 to that in 2012?
Give a very brief answer. 0.98. What is the difference between the highest and the second highest Insurance services (% of service imports) in Argentina?
Your answer should be compact. 1.27. What is the difference between the highest and the second highest Insurance services (% of service imports) of El Salvador?
Ensure brevity in your answer.  2.54. What is the difference between the highest and the second highest Insurance services (% of service imports) of St. Vincent and the Grenadines?
Provide a short and direct response. 0.28. What is the difference between the highest and the lowest Insurance services (% of service imports) of Argentina?
Keep it short and to the point. 3.43. What is the difference between the highest and the lowest Insurance services (% of service imports) in El Salvador?
Keep it short and to the point. 5.69. What is the difference between the highest and the lowest Insurance services (% of service imports) of St. Vincent and the Grenadines?
Provide a succinct answer. 2.51. 